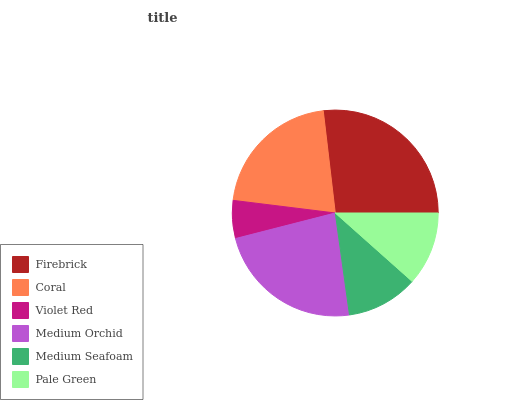Is Violet Red the minimum?
Answer yes or no. Yes. Is Firebrick the maximum?
Answer yes or no. Yes. Is Coral the minimum?
Answer yes or no. No. Is Coral the maximum?
Answer yes or no. No. Is Firebrick greater than Coral?
Answer yes or no. Yes. Is Coral less than Firebrick?
Answer yes or no. Yes. Is Coral greater than Firebrick?
Answer yes or no. No. Is Firebrick less than Coral?
Answer yes or no. No. Is Coral the high median?
Answer yes or no. Yes. Is Pale Green the low median?
Answer yes or no. Yes. Is Violet Red the high median?
Answer yes or no. No. Is Medium Seafoam the low median?
Answer yes or no. No. 